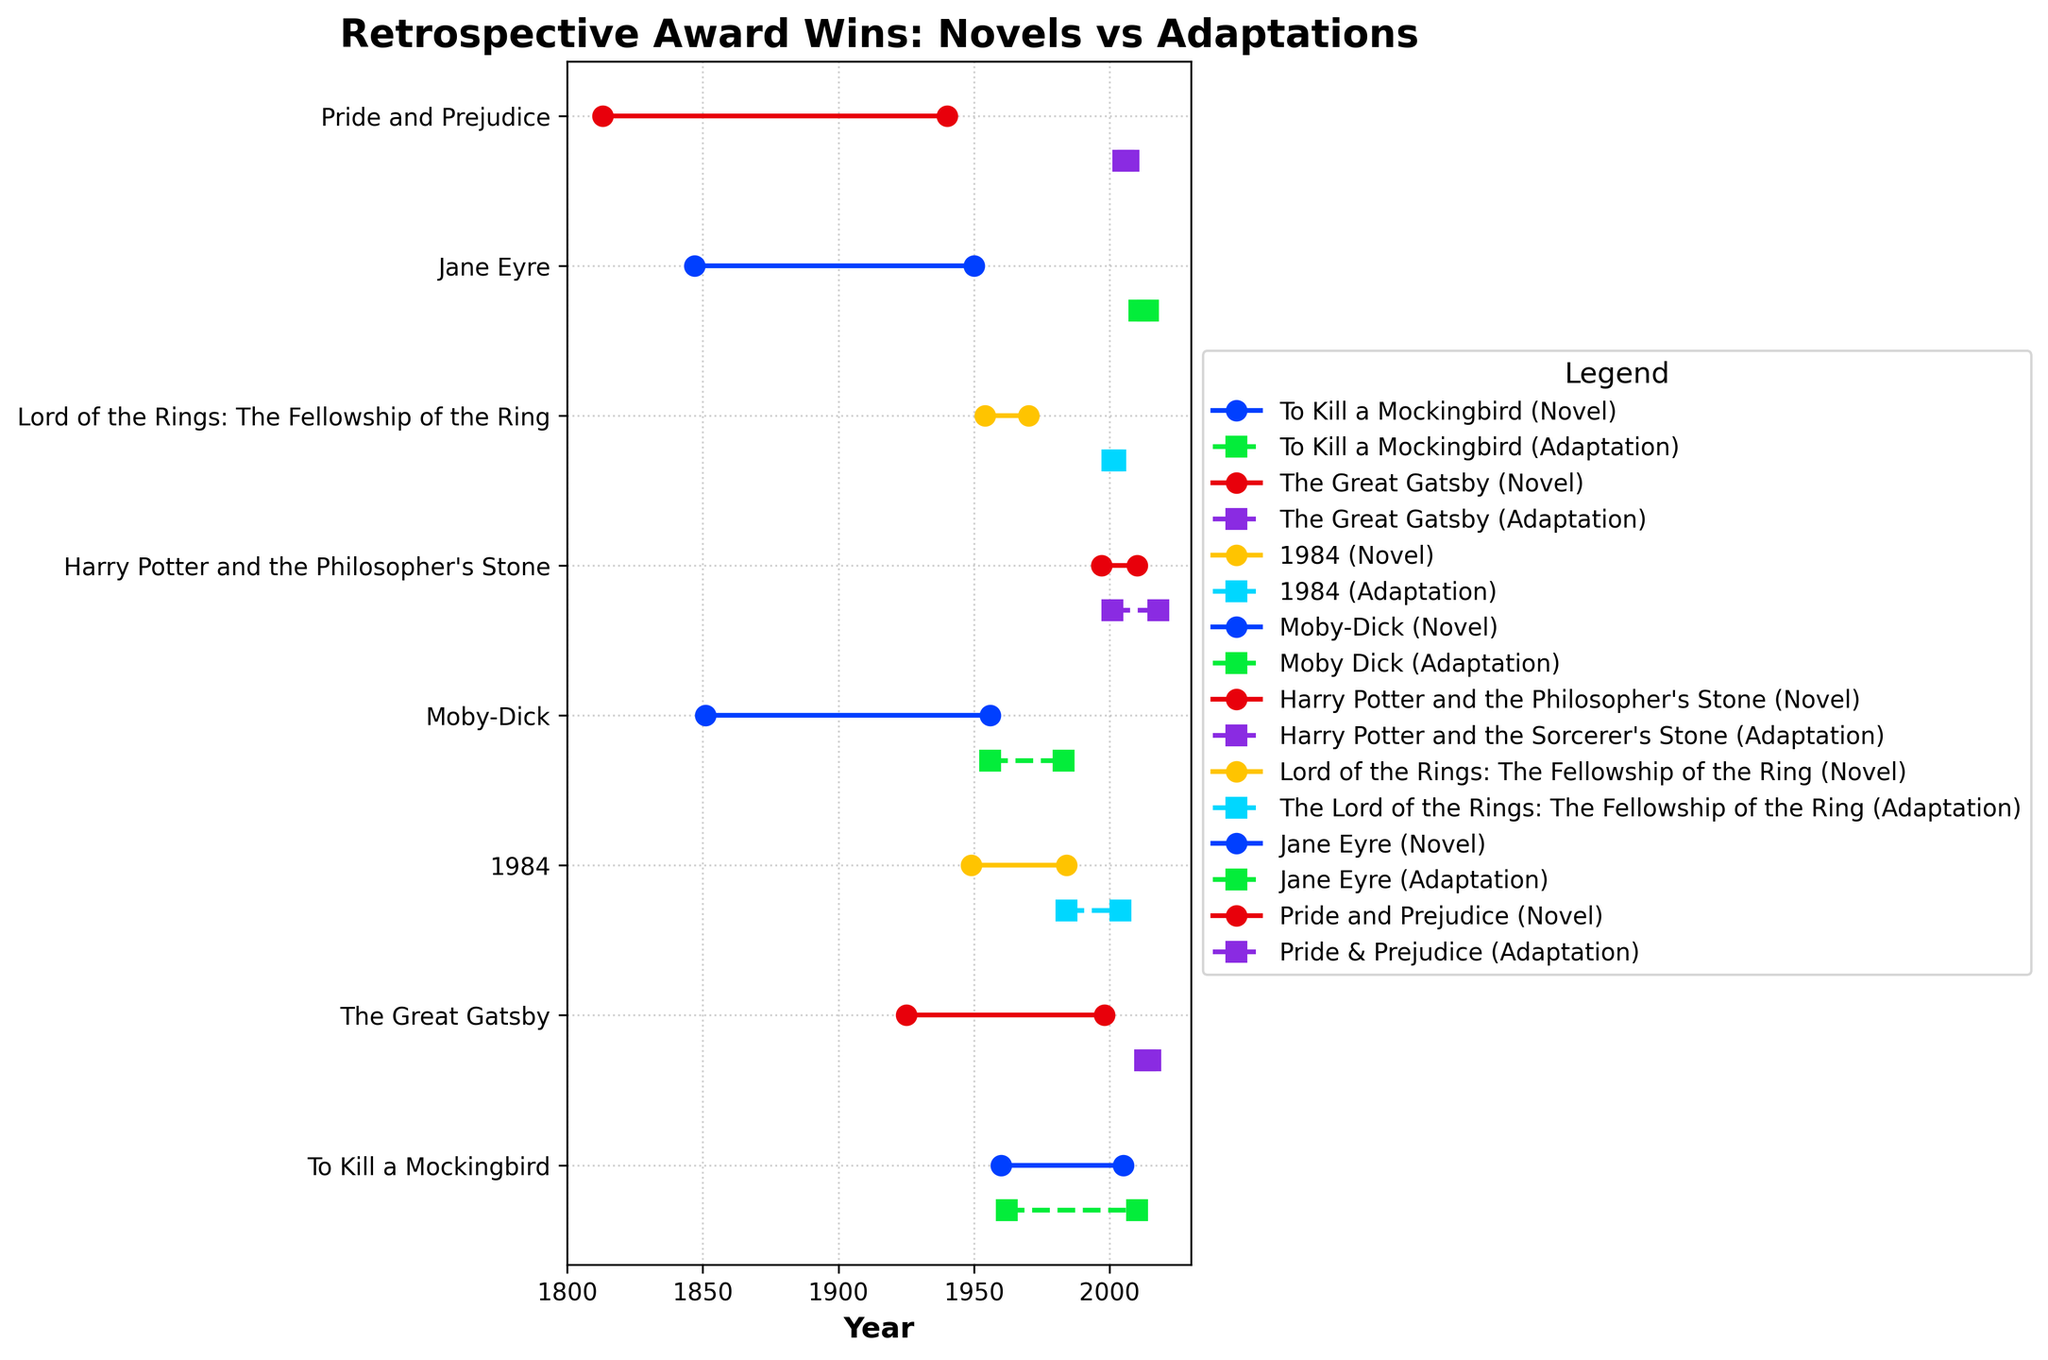What is the title of the figure? The title of the figure is typically found at the top center of the plot. In this figure, you can see the text "Retrospective Award Wins: Novels vs Adaptations" at the top.
Answer: Retrospective Award Wins: Novels vs Adaptations What is the range of years displayed on the X-axis? The range of years displayed on the X-axis can be identified by looking at the leftmost and rightmost labels on the horizontal axis. In this figure, the X-axis ranges from 1800 to 2030.
Answer: 1800 to 2030 How many novels are shown in the figure? Count the number of unique labels on the Y-axis, each of which represents a novel. There are 8 labels on the Y-axis corresponding to 8 different novels in the figure.
Answer: 8 Which novel has the longest time between its publication and its adaptation winning a retrospective award? For each novel, calculate the difference between the year of retrospective award for adaptation and the year of publication. The novel with the largest difference is "Pride and Prejudice" with a span from 1813 to 2007, which is 194 years.
Answer: Pride and Prejudice What is the difference in years between the retrospective award for the novel "1984" and its adaptation? Look at the points for "1984" and note the year of retrospective award for both the novel and its adaptation. For the novel, it's 1984, and for the adaptation, it's 2004. The difference is 2004 - 1984 = 20 years.
Answer: 20 years Which novel and its adaptation both received awards in the shortest amount of time after their release? Calculate the duration from the publication of the novel to its award year, and the release of the adaptation to its award year. "1984" (both the novel published and awarded in 1984, and adaptation awarded in 2004) has the shortest combined time span of 24 years.
Answer: 1984 Which adaptation received a retrospective award the quickest after its release? By looking at the step plots for each adaptation, identify the shortest span between the release of the adaptation and its award year. The adaptation of "The Lord of the Rings: The Fellowship of the Ring" received an award just one year after its release, in 2002.
Answer: The Lord of the Rings: The Fellowship of the Ring What is the average span of years between novel publication and their first retrospective award? For each novel, calculate the difference between the year of publication and the year of its first retrospective award, then take the average of these differences:
"To Kill a Mockingbird": 2005 - 1960 = 45 years
"The Great Gatsby": 1998 - 1925 = 73 years
"1984": 1984 - 1949 = 35 years
"Moby-Dick": 1956 - 1851 = 105 years
"Harry Potter and the Philosopher's Stone": 2010 - 1997 = 13 years
"Lord of the Rings: The Fellowship of the Ring": 1970 - 1954 = 16 years
"Jane Eyre": 1950 - 1847 = 103 years
"Pride and Prejudice": 1940 - 1813 = 127 years
Average = (45 + 73 + 35 + 105 + 13 + 16 + 103 + 127) / 8 = 64.625 years
Answer: 64.625 years 